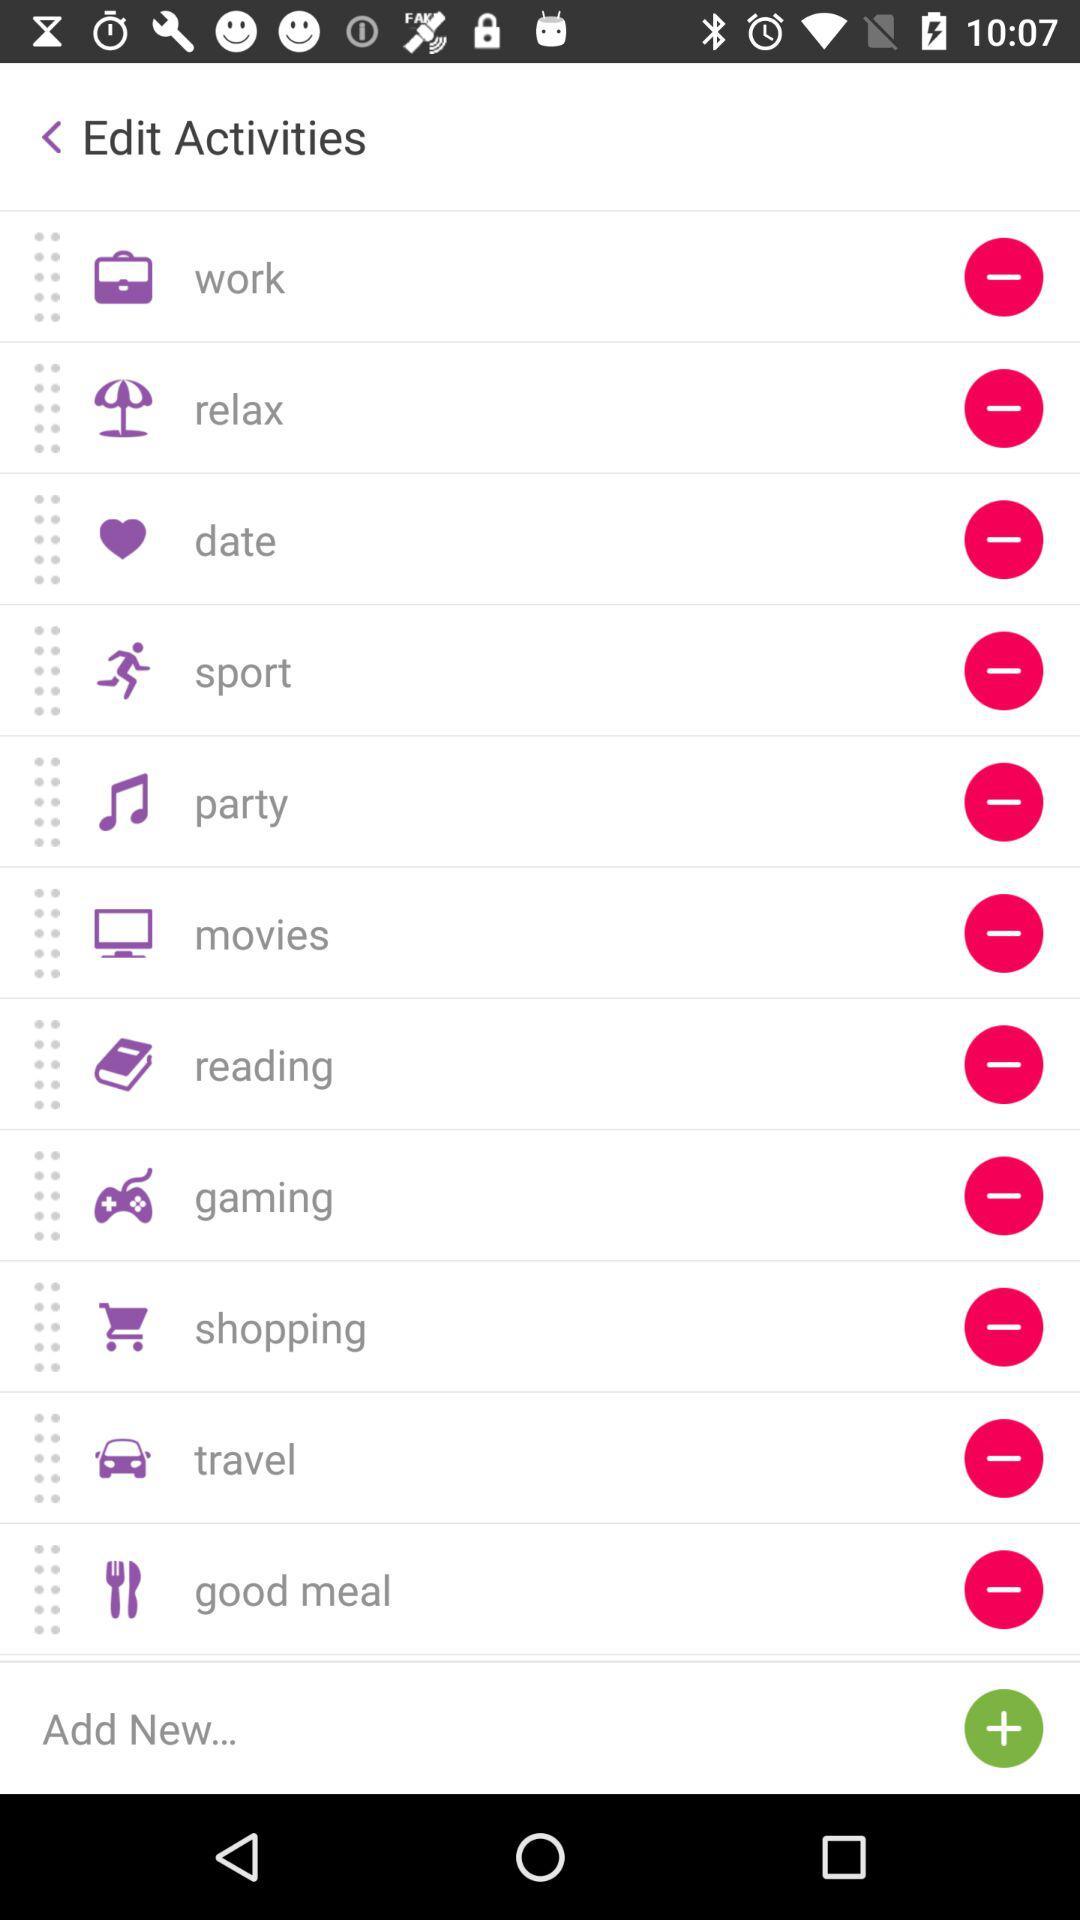What are the options available in "Activities"? The available options in "Activities" are "work", "relax", "date", "sport", "party", "movies", "reading", "gaming", "shopping", "travel" and "good meal". 